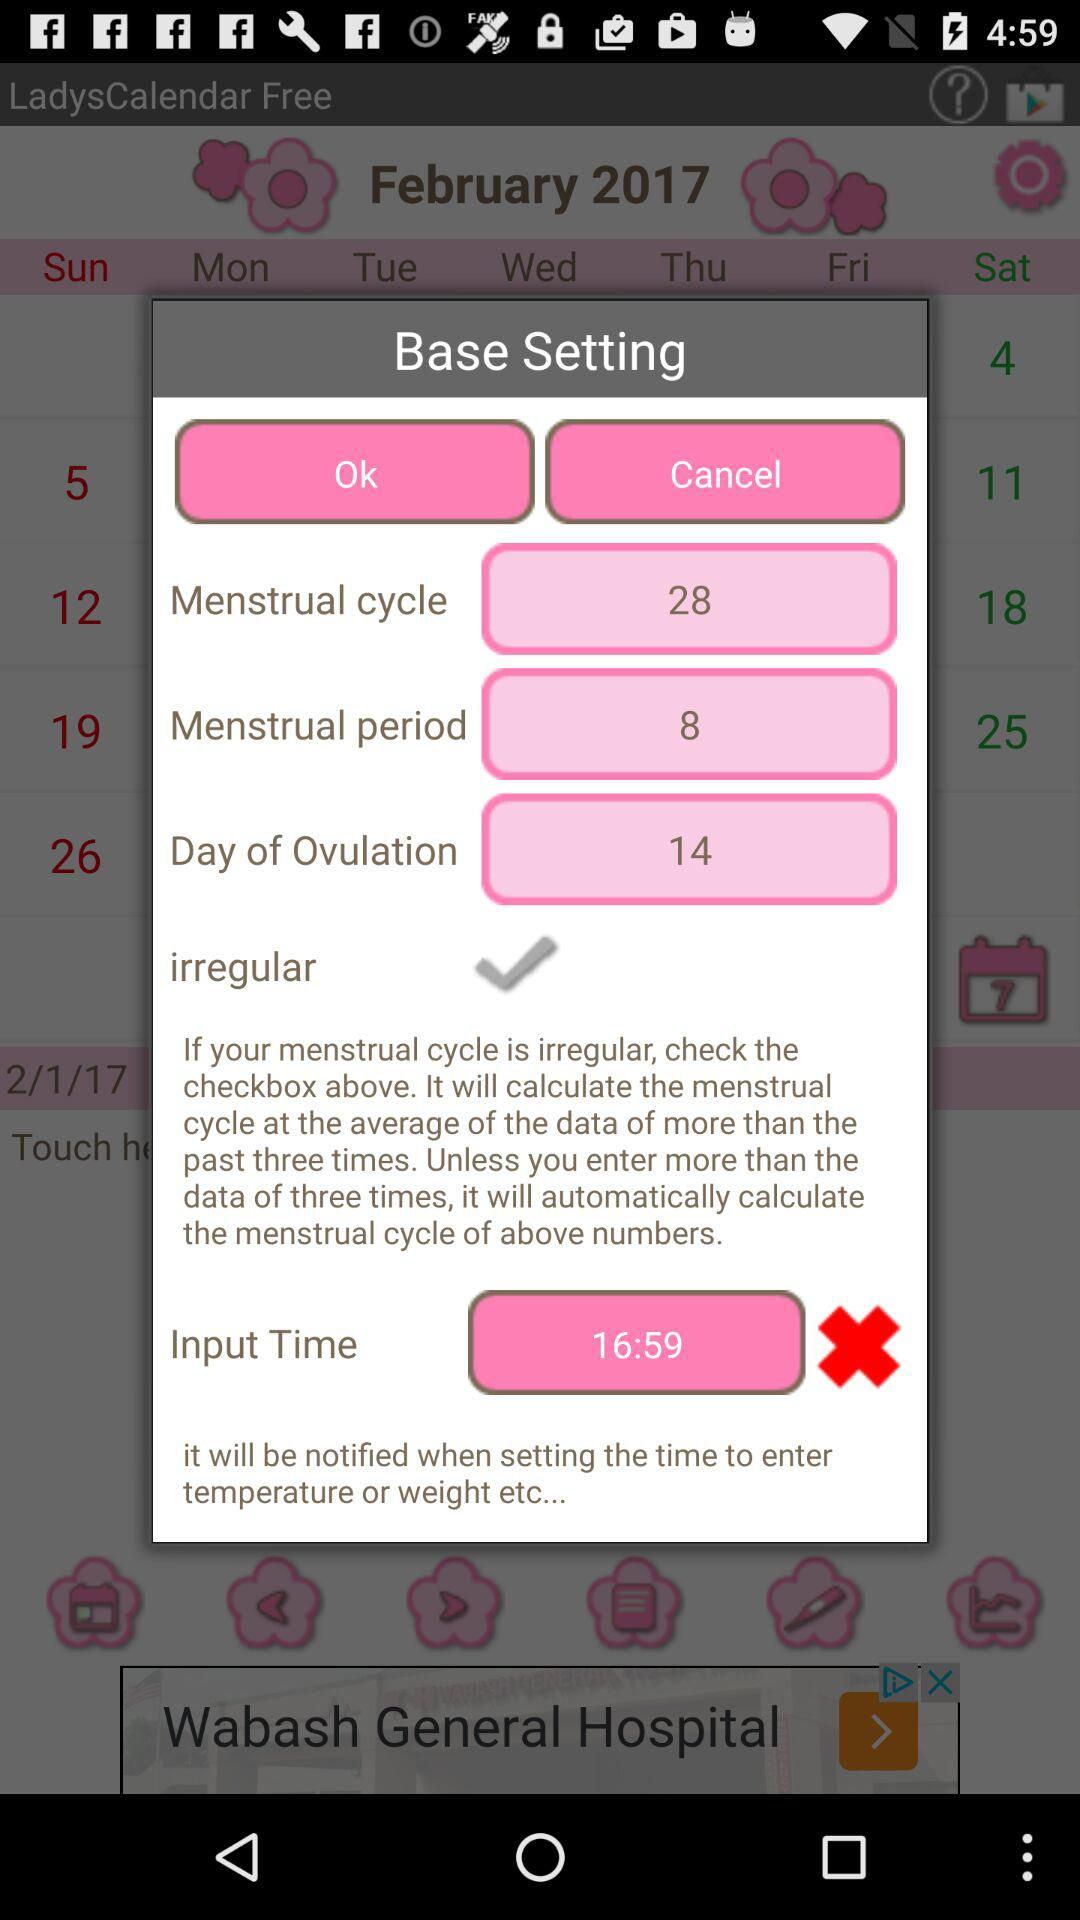When does ovulation occur? Ovulation occurs on the 14th day. 